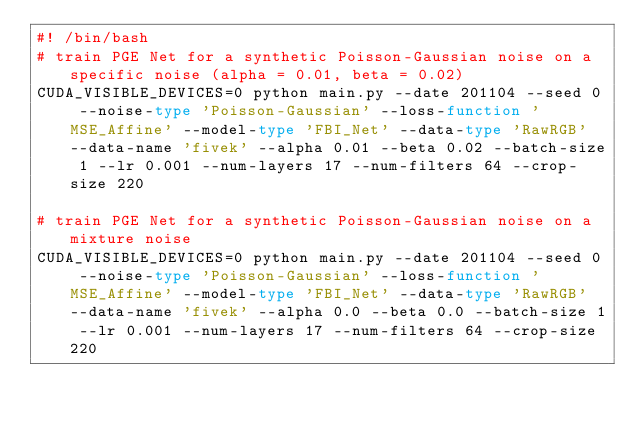Convert code to text. <code><loc_0><loc_0><loc_500><loc_500><_Bash_>#! /bin/bash
# train PGE Net for a synthetic Poisson-Gaussian noise on a specific noise (alpha = 0.01, beta = 0.02)
CUDA_VISIBLE_DEVICES=0 python main.py --date 201104 --seed 0 --noise-type 'Poisson-Gaussian' --loss-function 'MSE_Affine' --model-type 'FBI_Net' --data-type 'RawRGB' --data-name 'fivek' --alpha 0.01 --beta 0.02 --batch-size 1 --lr 0.001 --num-layers 17 --num-filters 64 --crop-size 220 

# train PGE Net for a synthetic Poisson-Gaussian noise on a mixture noise
CUDA_VISIBLE_DEVICES=0 python main.py --date 201104 --seed 0 --noise-type 'Poisson-Gaussian' --loss-function 'MSE_Affine' --model-type 'FBI_Net' --data-type 'RawRGB' --data-name 'fivek' --alpha 0.0 --beta 0.0 --batch-size 1 --lr 0.001 --num-layers 17 --num-filters 64 --crop-size 220 </code> 